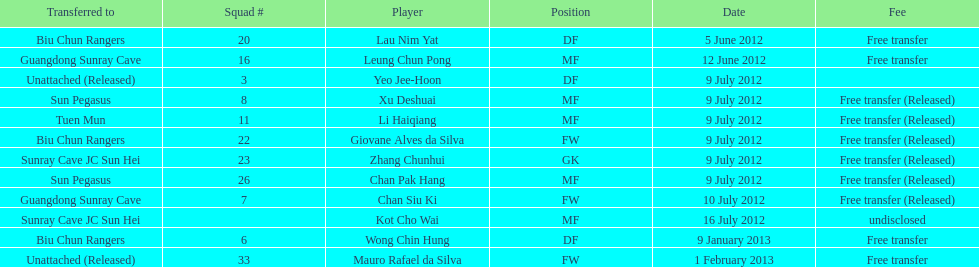Li haiqiang and xu deshuai both played which position? MF. 